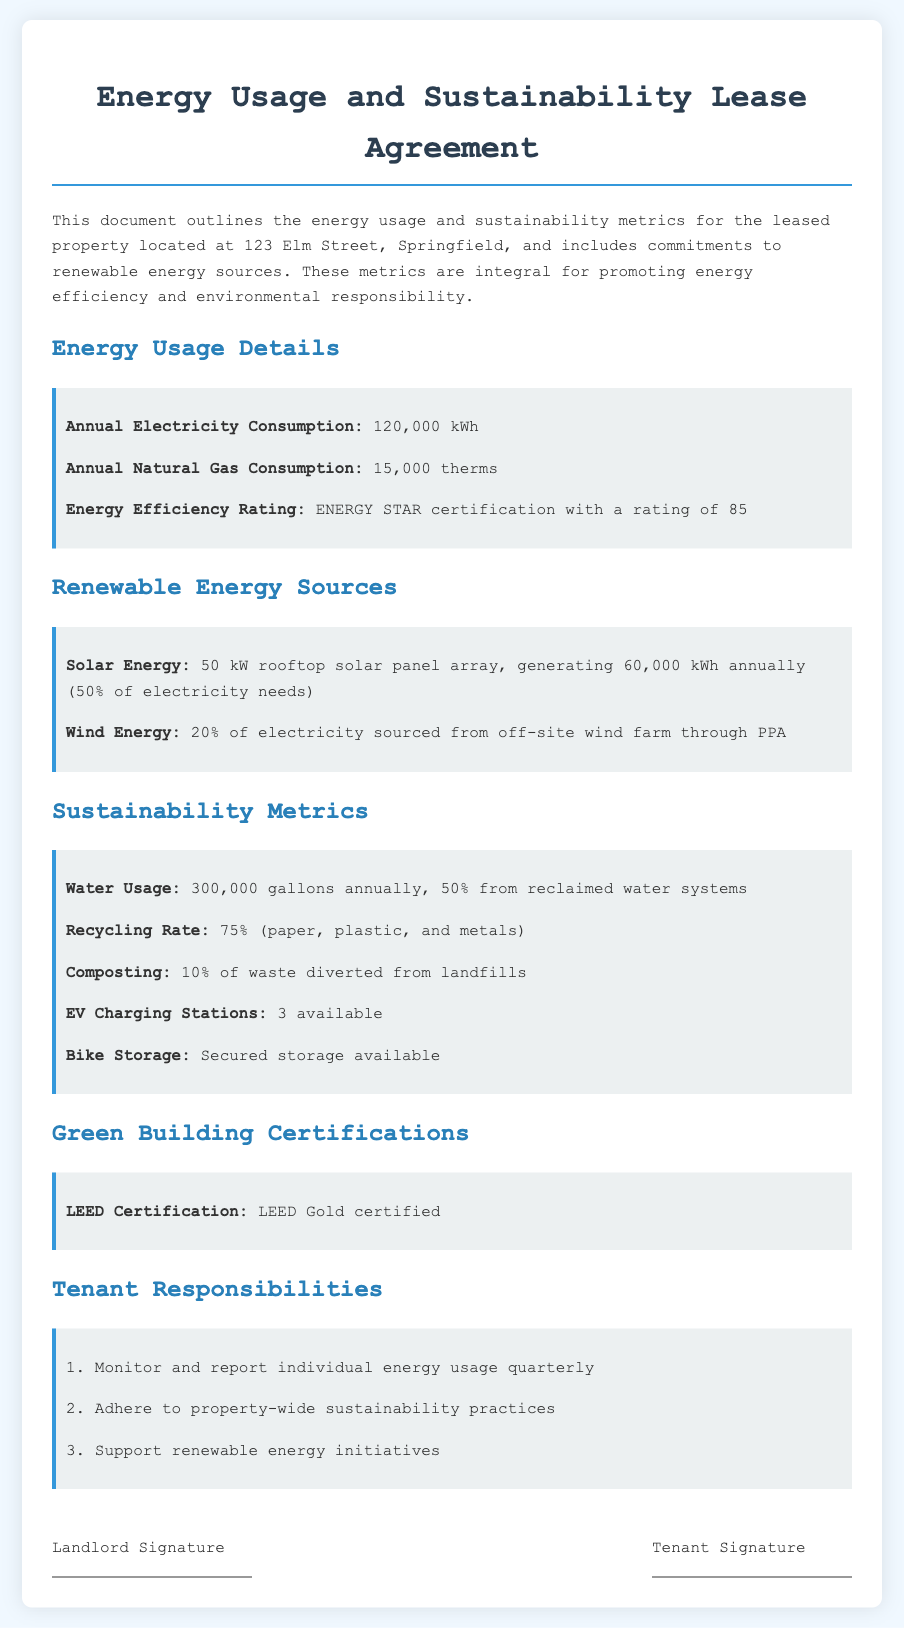what is the annual electricity consumption? The annual electricity consumption is explicitly mentioned in the document under "Energy Usage Details."
Answer: 120,000 kWh what percentage of electricity needs is generated from solar energy? The solar energy contribution is detailed in the "Renewable Energy Sources" section, stating that it generates 50% of electricity needs.
Answer: 50% how many EV charging stations are available? The number of EV charging stations is listed in the "Sustainability Metrics" section of the lease agreement.
Answer: 3 what is the energy efficiency rating? The energy efficiency rating is provided under "Energy Usage Details," citing the ENERGY STAR certification.
Answer: ENERGY STAR certification with a rating of 85 what is the recycling rate mentioned in the document? The recycling rate is found in the "Sustainability Metrics" section indicating the percentage of recyclable materials.
Answer: 75% what is the LEED certification level of the property? The level of LEED certification is noted in the "Green Building Certifications" section of the document.
Answer: LEED Gold certified what is the annual natural gas consumption? The annual natural gas consumption is specified under the "Energy Usage Details" heading.
Answer: 15,000 therms what are the tenant responsibilities outlined in the agreement? The tenant responsibilities are listed clearly in a separate section with three distinct points under "Tenant Responsibilities."
Answer: Monitor and report individual energy usage quarterly, adhere to property-wide sustainability practices, support renewable energy initiatives 